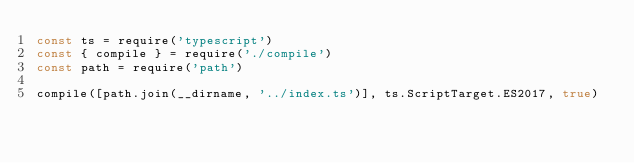Convert code to text. <code><loc_0><loc_0><loc_500><loc_500><_JavaScript_>const ts = require('typescript')
const { compile } = require('./compile')
const path = require('path')

compile([path.join(__dirname, '../index.ts')], ts.ScriptTarget.ES2017, true)
</code> 